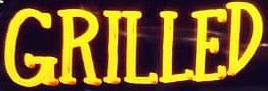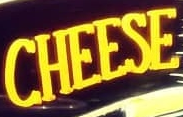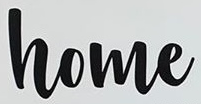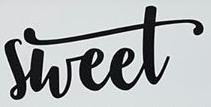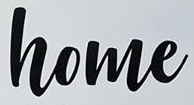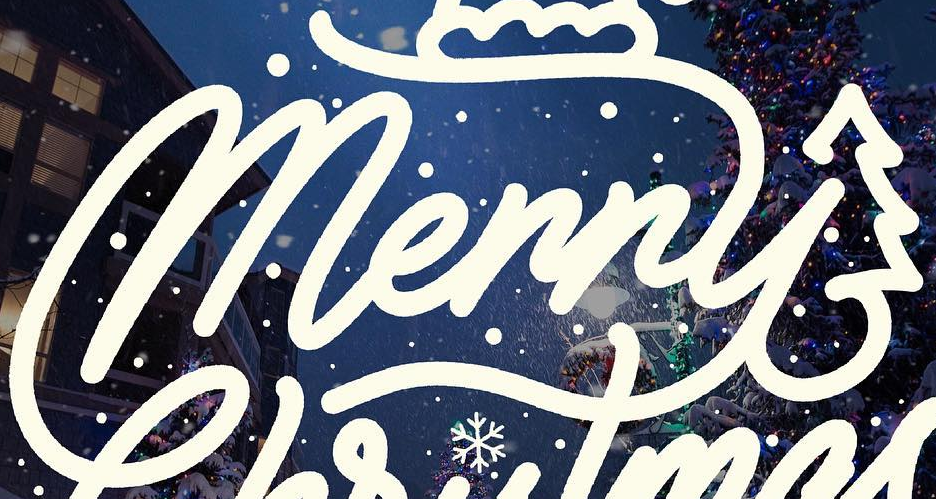What text is displayed in these images sequentially, separated by a semicolon? GRILLED; CHEESE; home; sheet; home; Merry 